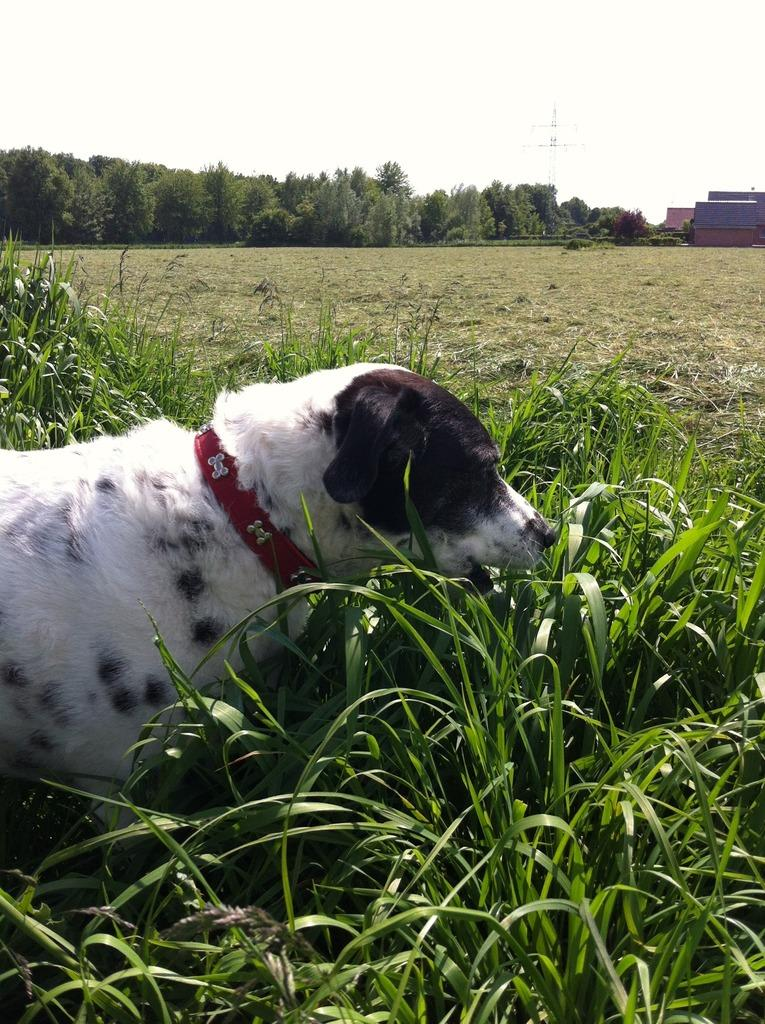What type of animal is in the image? There is a white dog in the image. Where is the dog located in the image? The dog is standing in the grass. What can be seen in the background of the image? There are houses, trees, and a tower in the background of the image. What is the condition of the sky in the image? The sky is plain in the background of the image. How many rings does the dog have on its legs in the image? There are no rings visible on the dog's legs in the image. Why is the dog crying in the image? There is no indication that the dog is crying in the image; it appears to be standing in the grass calmly. 